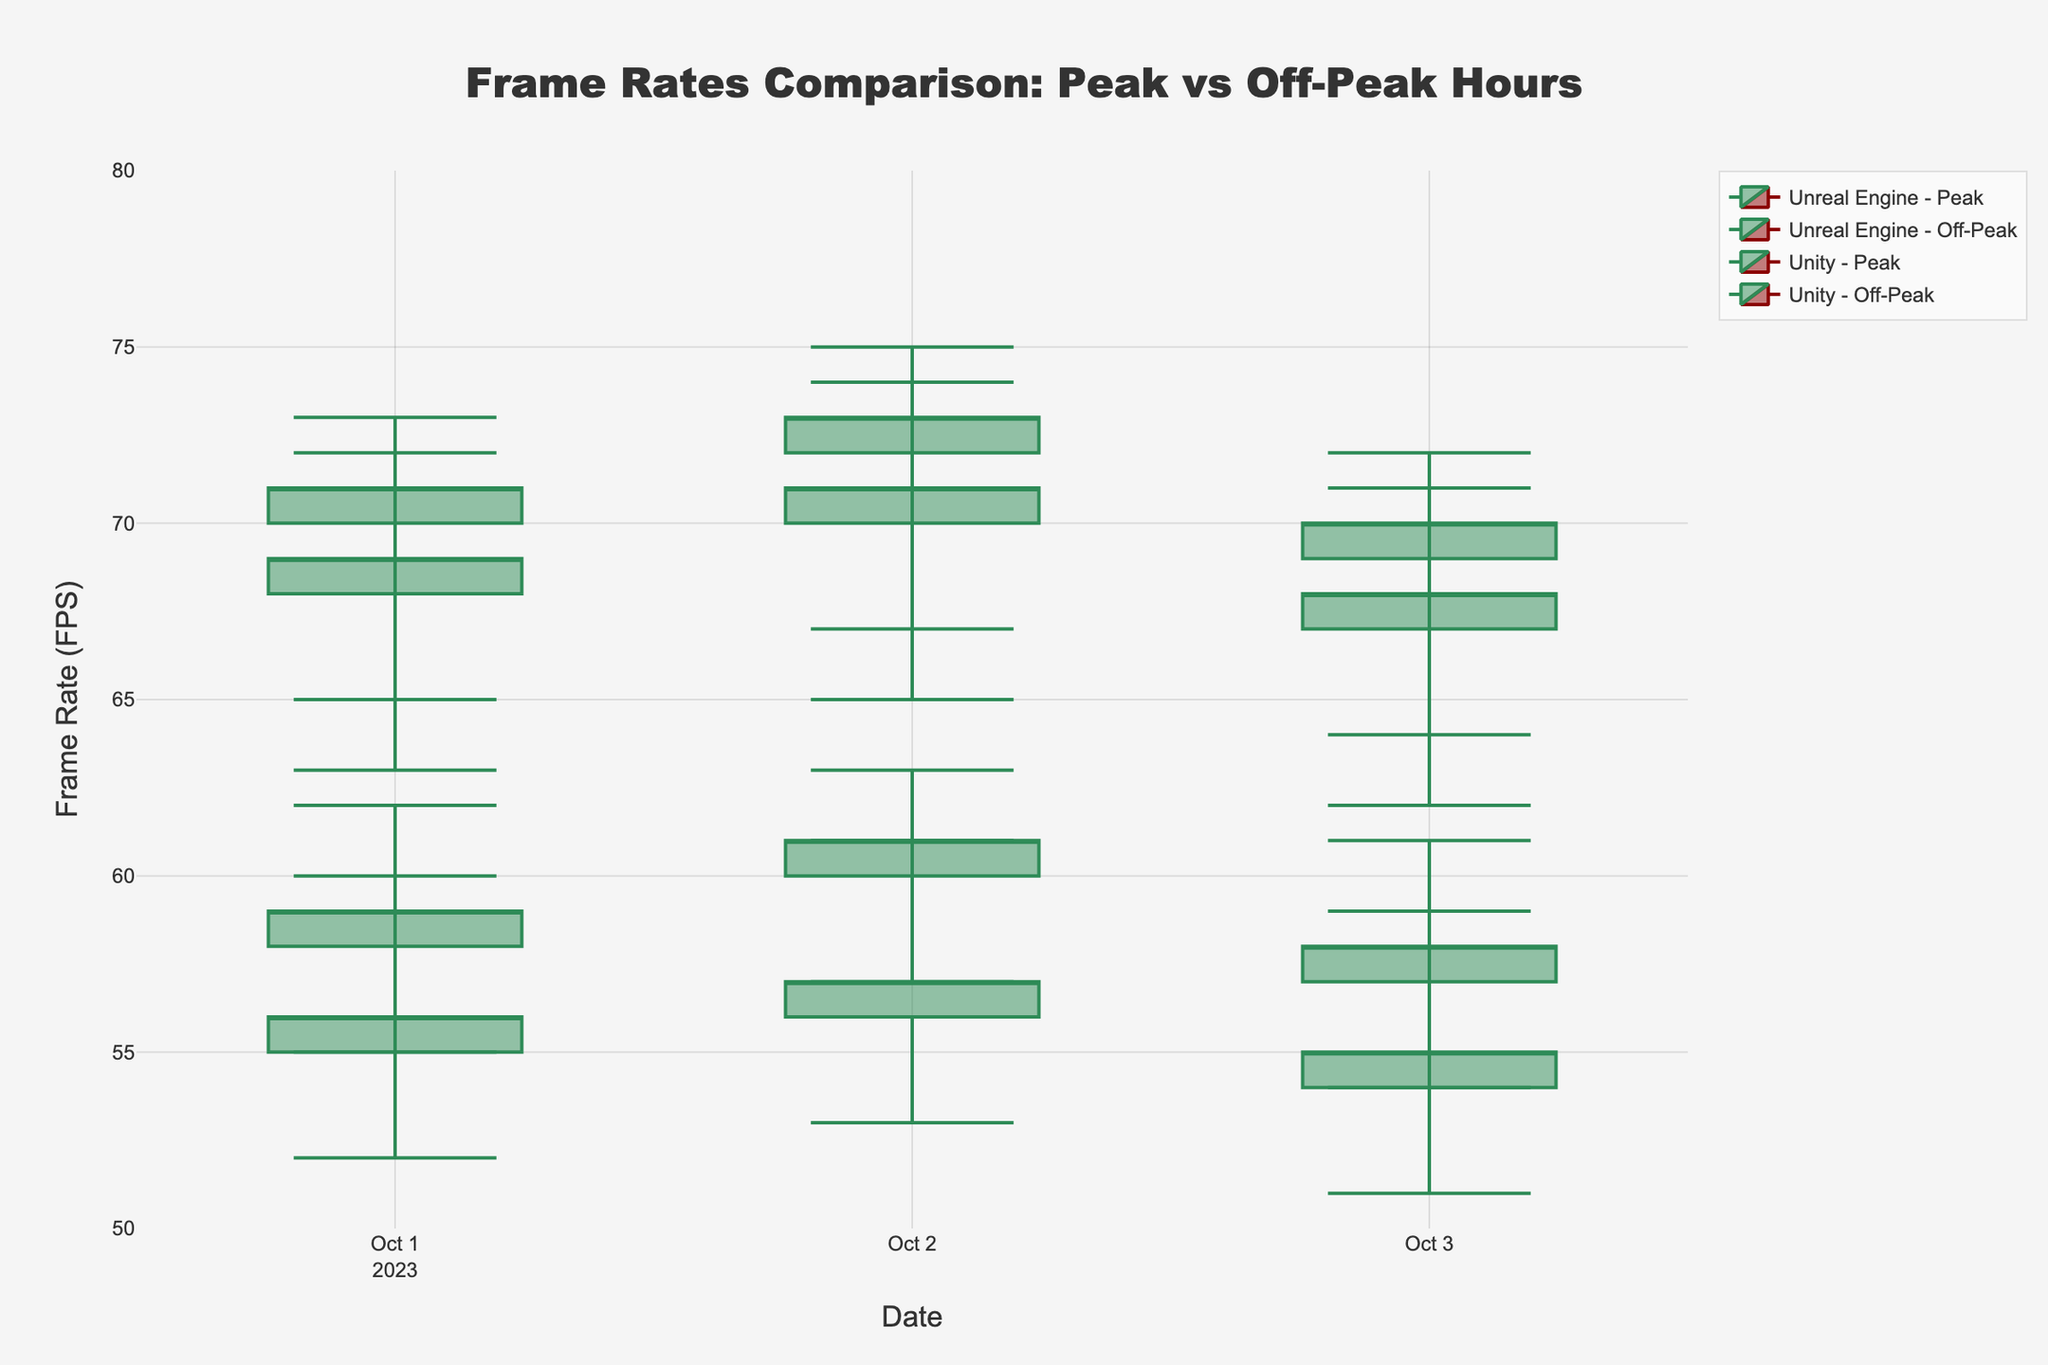What is the highest frame rate recorded for Unreal Engine during peak hours? To find the highest frame rate during peak hours for Unreal Engine, look at all the "High" values for Unreal Engine under the "Peak" period. The values are 62, 63, and 61. The highest among these is 63.
Answer: 63 What is the average closing frame rate for Unity during off-peak hours? To find the average closing frame rate during off-peak hours for Unity, take the average of the "Close" values for these periods: 69, 71, and 68. Sum these values (69 + 71 + 68 = 208) and divide by 3 to get the average, which is 69.33.
Answer: 69.33 During which day did Unity experience the lowest frame rate during peak hours? To answer this, look at the "Low" values for Unity during peak hours. The "Low" values are 52, 53, and 51 for the respective days. The lowest value is 51, which occurred on 2023-10-03.
Answer: 2023-10-03 How does the closing frame rate of Unreal Engine during off-peak hours on October 1st compare to that on October 2nd? Look at the "Close" values for Unreal Engine during off-peak hours on both dates. On October 1st, the value is 71, and on October 2nd, it is 73. Comparing these values, the frame rate is higher on October 2nd by 2 FPS.
Answer: 2 FPS higher What was the difference between the highest frame rates recorded for Unity and Unreal Engine during off-peak hours on October 1st? The highest frame rate for Unity during off-peak hours on October 1st is 72, and the highest for Unreal Engine on the same day is 73. The difference is 73 - 72 = 1.
Answer: 1 Which game engine had a higher fluctuation in frame rates during off-peak hours on October 3rd? Fluctuation can be determined by looking at the range (High - Low) for both engines. Unreal Engine's range is 72 - 64 = 8, and Unity's range is 71 - 62 = 9. Unity had a higher fluctuation.
Answer: Unity On which date did both game engines have the highest closing frame rate during off-peak hours? Look at the "Close" values for both engines during off-peak hours for each date. Unreal Engine had the highest closing frame rate of 73 on October 2nd, and Unity's highest was 71 on the same date. Thus, both engines had their highest closing frame rates on October 2nd.
Answer: 2023-10-02 What is the overall trend in the closing frame rate for Unreal Engine during peak hours over the three days? Look at the "Close" values for Unreal Engine during peak hours: 59, 61, and 58 for October 1st, 2nd, and 3rd, respectively. The values fluctuate slightly but do not show a consistent upward or downward trend.
Answer: No consistent trend 